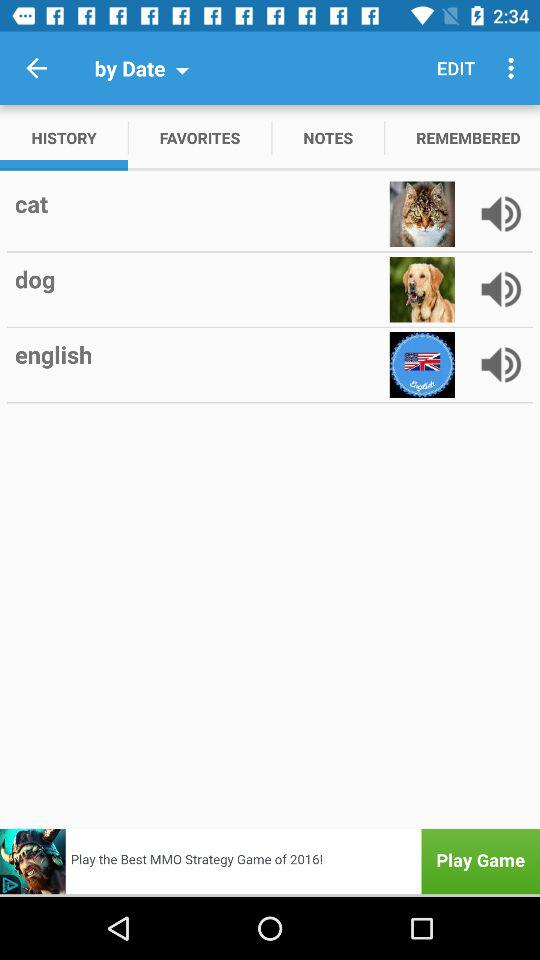Which tab is selected right now? The tab that is selected right now is "HISTORY". 